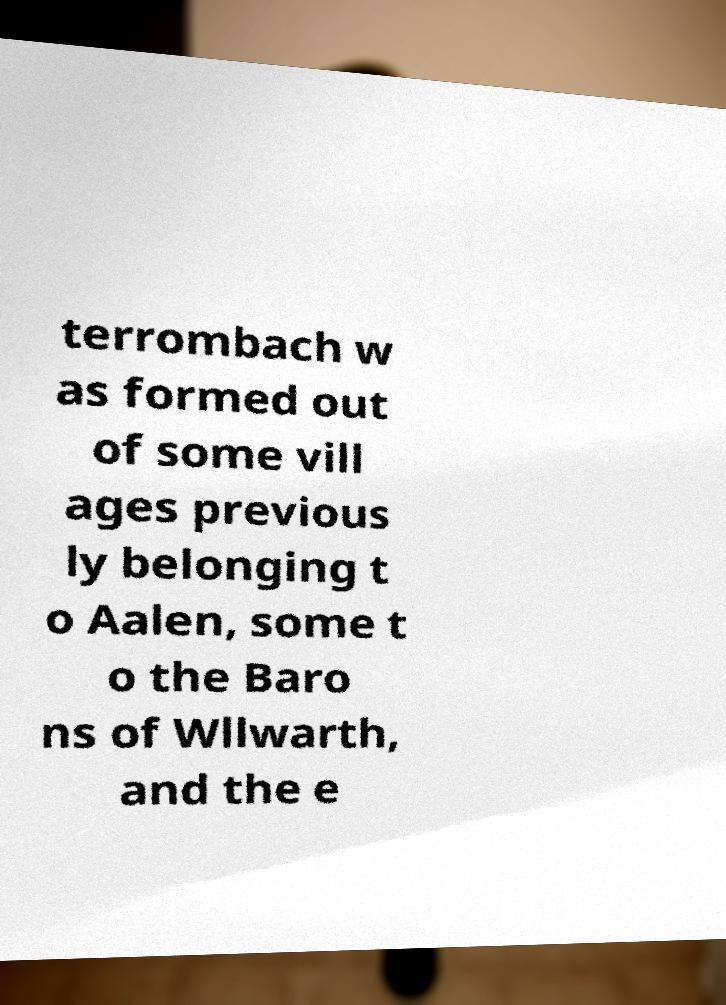I need the written content from this picture converted into text. Can you do that? terrombach w as formed out of some vill ages previous ly belonging t o Aalen, some t o the Baro ns of Wllwarth, and the e 